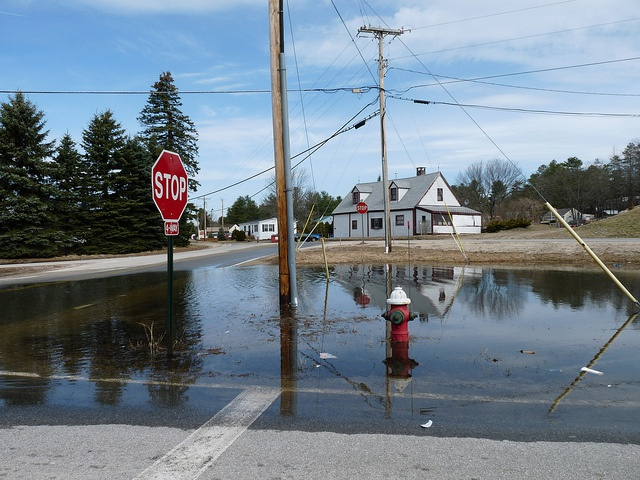Describe the objects in this image and their specific colors. I can see stop sign in lightblue, maroon, lightgray, and darkgray tones, fire hydrant in lightblue, black, lightgray, maroon, and brown tones, car in lightblue, black, gray, and darkgray tones, and stop sign in lightblue, maroon, and brown tones in this image. 